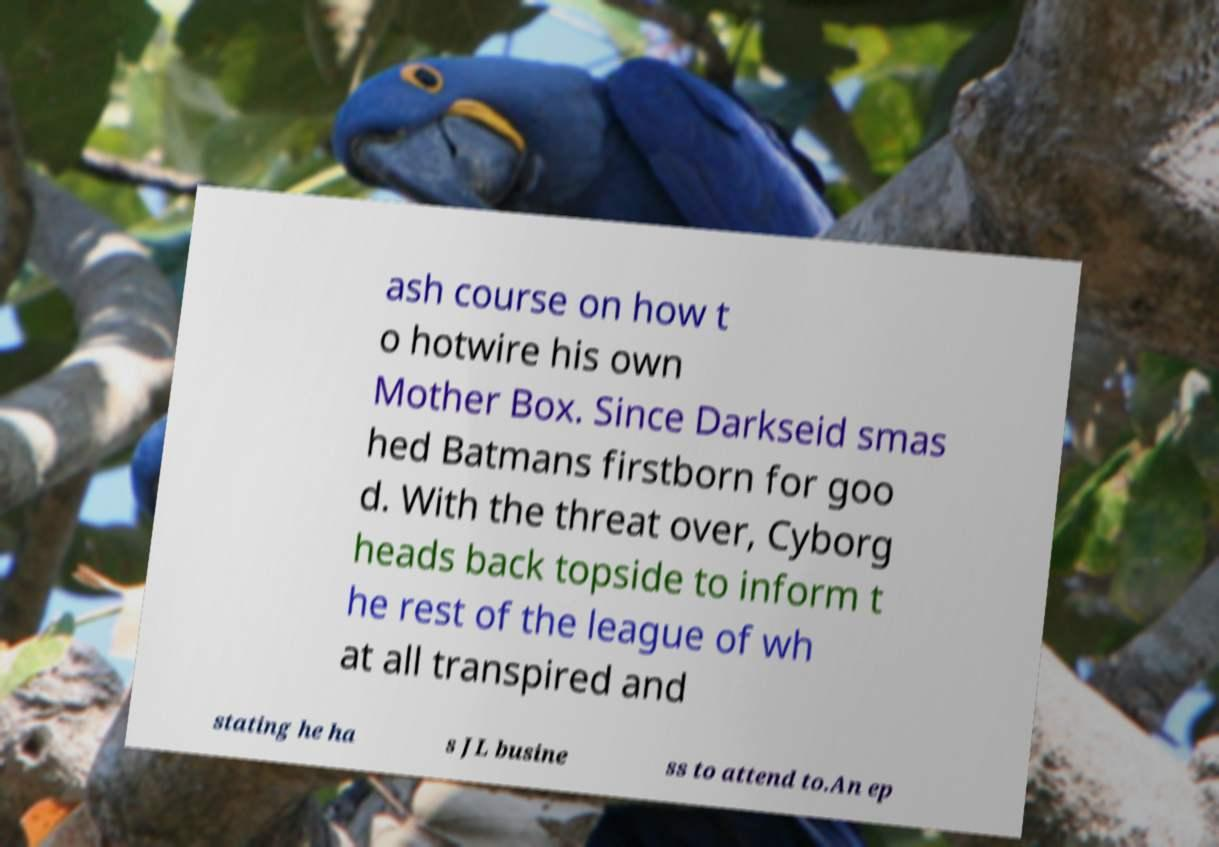What messages or text are displayed in this image? I need them in a readable, typed format. ash course on how t o hotwire his own Mother Box. Since Darkseid smas hed Batmans firstborn for goo d. With the threat over, Cyborg heads back topside to inform t he rest of the league of wh at all transpired and stating he ha s JL busine ss to attend to.An ep 